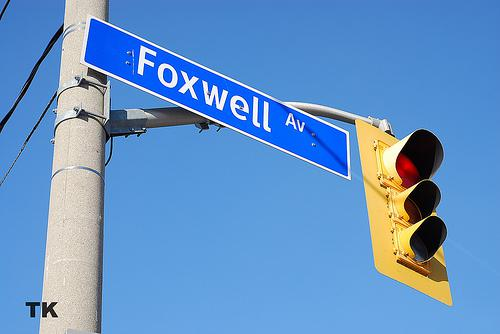Question: what is written on the sign?
Choices:
A. Stop.
B. 3rd St.
C. Marlboro Dr.
D. Foxwell Ave.
Answer with the letter. Answer: D Question: who is in the photo?
Choices:
A. A man.
B. A woman.
C. A boy.
D. Nobody.
Answer with the letter. Answer: D Question: what is next to the sign?
Choices:
A. Pedestrians.
B. A car.
C. A bus.
D. Traffic lights.
Answer with the letter. Answer: D Question: when was the photo taken?
Choices:
A. Morning.
B. Noon.
C. During the day.
D. Night.
Answer with the letter. Answer: C 